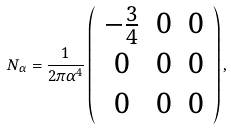<formula> <loc_0><loc_0><loc_500><loc_500>N _ { \alpha } = \frac { 1 } { 2 \pi \alpha ^ { 4 } } \left ( \begin{array} { c c c } - \frac { 3 } { 4 } & 0 & 0 \\ 0 & 0 & 0 \\ 0 & 0 & 0 \end{array} \right ) ,</formula> 